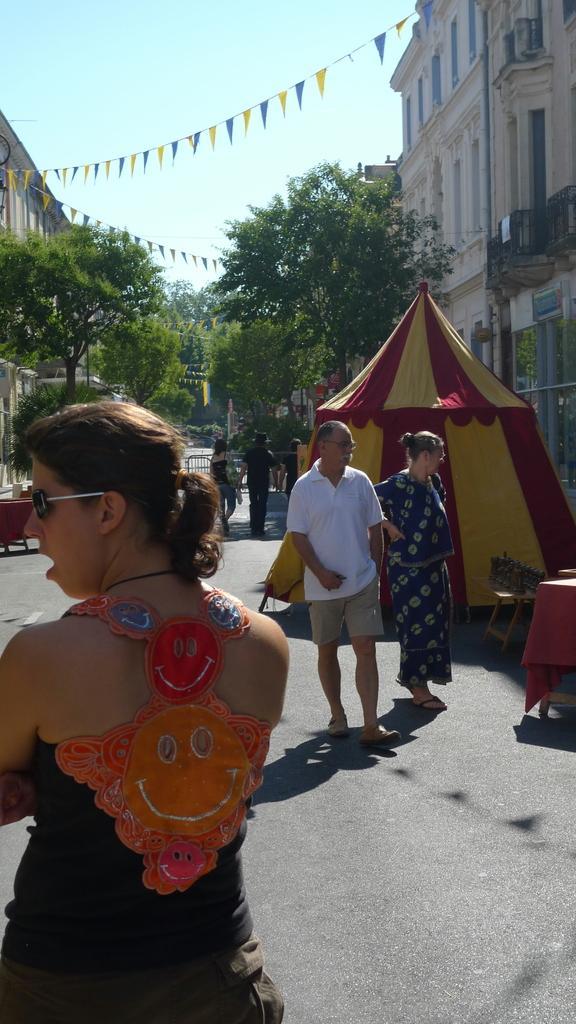Can you describe this image briefly? In this image there are a few people walking down the street, on the street there are tents, on the either side of the street there are trees and buildings. 